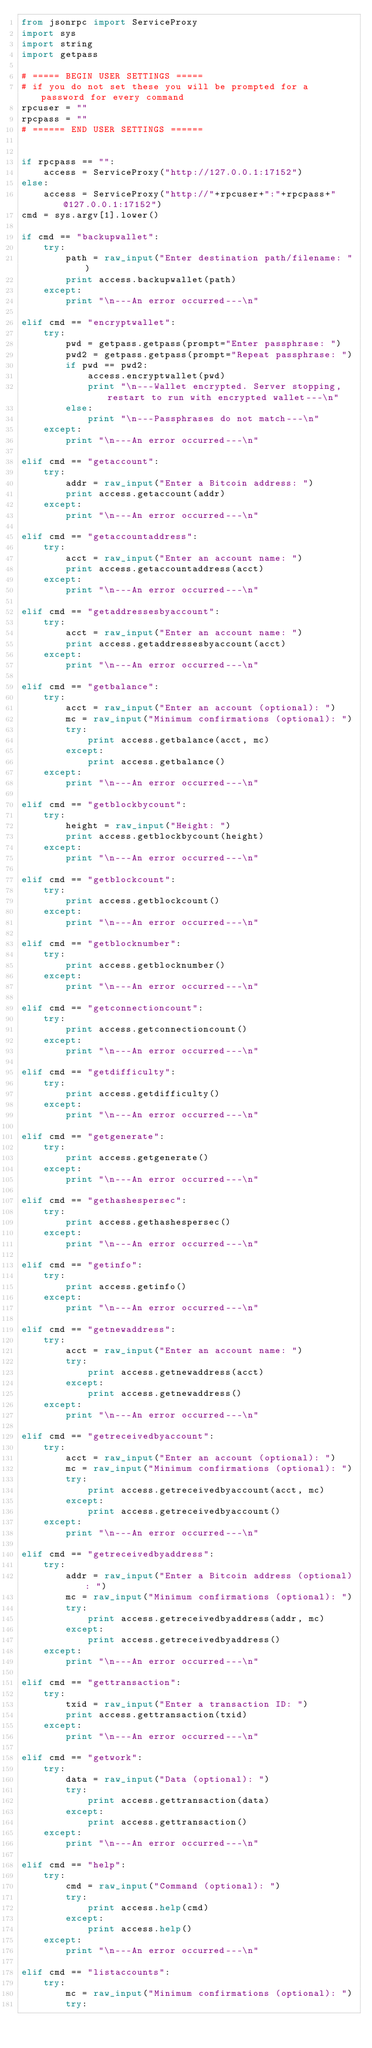<code> <loc_0><loc_0><loc_500><loc_500><_Python_>from jsonrpc import ServiceProxy
import sys
import string
import getpass

# ===== BEGIN USER SETTINGS =====
# if you do not set these you will be prompted for a password for every command
rpcuser = ""
rpcpass = ""
# ====== END USER SETTINGS ======


if rpcpass == "":
    access = ServiceProxy("http://127.0.0.1:17152")
else:
    access = ServiceProxy("http://"+rpcuser+":"+rpcpass+"@127.0.0.1:17152")
cmd = sys.argv[1].lower()

if cmd == "backupwallet":
    try:
        path = raw_input("Enter destination path/filename: ")
        print access.backupwallet(path)
    except:
        print "\n---An error occurred---\n"
        
elif cmd == "encryptwallet":
    try:
        pwd = getpass.getpass(prompt="Enter passphrase: ")
        pwd2 = getpass.getpass(prompt="Repeat passphrase: ")
        if pwd == pwd2:
            access.encryptwallet(pwd)
            print "\n---Wallet encrypted. Server stopping, restart to run with encrypted wallet---\n"
        else:
            print "\n---Passphrases do not match---\n"
    except:
        print "\n---An error occurred---\n"

elif cmd == "getaccount":
    try:
        addr = raw_input("Enter a Bitcoin address: ")
        print access.getaccount(addr)
    except:
        print "\n---An error occurred---\n"

elif cmd == "getaccountaddress":
    try:
        acct = raw_input("Enter an account name: ")
        print access.getaccountaddress(acct)
    except:
        print "\n---An error occurred---\n"

elif cmd == "getaddressesbyaccount":
    try:
        acct = raw_input("Enter an account name: ")
        print access.getaddressesbyaccount(acct)
    except:
        print "\n---An error occurred---\n"

elif cmd == "getbalance":
    try:
        acct = raw_input("Enter an account (optional): ")
        mc = raw_input("Minimum confirmations (optional): ")
        try:
            print access.getbalance(acct, mc)
        except:
            print access.getbalance()
    except:
        print "\n---An error occurred---\n"

elif cmd == "getblockbycount":
    try:
        height = raw_input("Height: ")
        print access.getblockbycount(height)
    except:
        print "\n---An error occurred---\n"

elif cmd == "getblockcount":
    try:
        print access.getblockcount()
    except:
        print "\n---An error occurred---\n"

elif cmd == "getblocknumber":
    try:
        print access.getblocknumber()
    except:
        print "\n---An error occurred---\n"

elif cmd == "getconnectioncount":
    try:
        print access.getconnectioncount()
    except:
        print "\n---An error occurred---\n"

elif cmd == "getdifficulty":
    try:
        print access.getdifficulty()
    except:
        print "\n---An error occurred---\n"

elif cmd == "getgenerate":
    try:
        print access.getgenerate()
    except:
        print "\n---An error occurred---\n"

elif cmd == "gethashespersec":
    try:
        print access.gethashespersec()
    except:
        print "\n---An error occurred---\n"

elif cmd == "getinfo":
    try:
        print access.getinfo()
    except:
        print "\n---An error occurred---\n"

elif cmd == "getnewaddress":
    try:
        acct = raw_input("Enter an account name: ")
        try:
            print access.getnewaddress(acct)
        except:
            print access.getnewaddress()
    except:
        print "\n---An error occurred---\n"

elif cmd == "getreceivedbyaccount":
    try:
        acct = raw_input("Enter an account (optional): ")
        mc = raw_input("Minimum confirmations (optional): ")
        try:
            print access.getreceivedbyaccount(acct, mc)
        except:
            print access.getreceivedbyaccount()
    except:
        print "\n---An error occurred---\n"

elif cmd == "getreceivedbyaddress":
    try:
        addr = raw_input("Enter a Bitcoin address (optional): ")
        mc = raw_input("Minimum confirmations (optional): ")
        try:
            print access.getreceivedbyaddress(addr, mc)
        except:
            print access.getreceivedbyaddress()
    except:
        print "\n---An error occurred---\n"

elif cmd == "gettransaction":
    try:
        txid = raw_input("Enter a transaction ID: ")
        print access.gettransaction(txid)
    except:
        print "\n---An error occurred---\n"

elif cmd == "getwork":
    try:
        data = raw_input("Data (optional): ")
        try:
            print access.gettransaction(data)
        except:
            print access.gettransaction()
    except:
        print "\n---An error occurred---\n"

elif cmd == "help":
    try:
        cmd = raw_input("Command (optional): ")
        try:
            print access.help(cmd)
        except:
            print access.help()
    except:
        print "\n---An error occurred---\n"

elif cmd == "listaccounts":
    try:
        mc = raw_input("Minimum confirmations (optional): ")
        try:</code> 